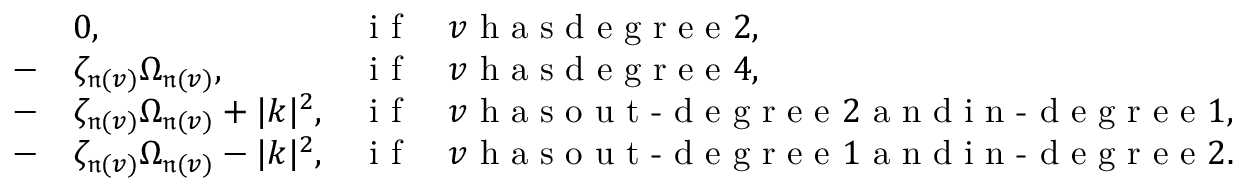Convert formula to latex. <formula><loc_0><loc_0><loc_500><loc_500>\begin{array} { r l r l } & { 0 , } & { i f } & { v h a s d e g r e e 2 , } \\ { - } & { \zeta _ { \mathfrak n ( v ) } \Omega _ { \mathfrak n ( v ) } , } & { i f } & { v h a s d e g r e e 4 , } \\ { - } & { \zeta _ { \mathfrak n ( v ) } \Omega _ { \mathfrak n ( v ) } + | k | ^ { 2 } , } & { i f } & { v h a s o u t - d e g r e e 2 a n d i n - d e g r e e 1 , } \\ { - } & { \zeta _ { \mathfrak n ( v ) } \Omega _ { \mathfrak n ( v ) } - | k | ^ { 2 } , } & { i f } & { v h a s o u t - d e g r e e 1 a n d i n - d e g r e e 2 . } \end{array}</formula> 